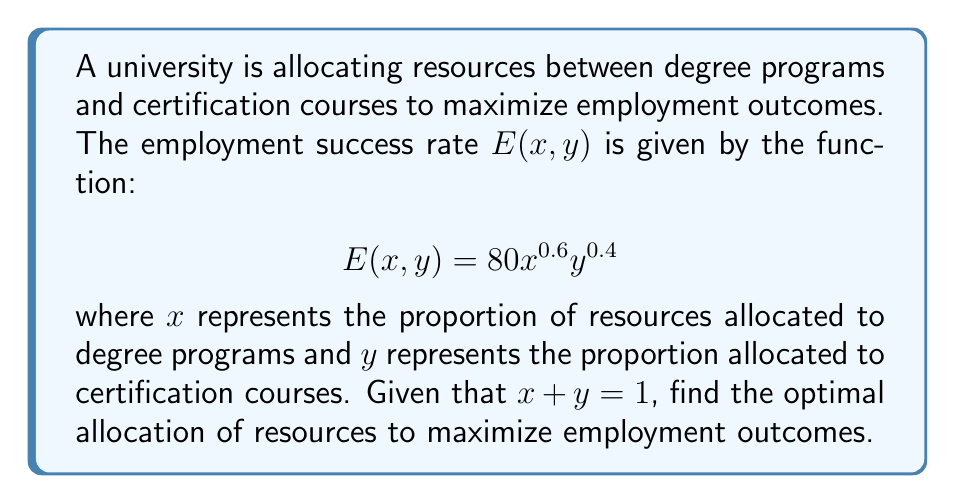What is the answer to this math problem? 1) First, we need to express $y$ in terms of $x$ using the constraint $x + y = 1$:
   $y = 1 - x$

2) Substitute this into the employment success rate function:
   $$E(x) = 80x^{0.6}(1-x)^{0.4}$$

3) To find the maximum, we need to differentiate $E(x)$ with respect to $x$ and set it to zero:
   $$\frac{dE}{dx} = 80[0.6x^{-0.4}(1-x)^{0.4} - 0.4x^{0.6}(1-x)^{-0.6}] = 0$$

4) Simplify:
   $$48x^{-0.4}(1-x)^{0.4} = 32x^{0.6}(1-x)^{-0.6}$$

5) Divide both sides by $32x^{-0.4}(1-x)^{-0.6}$:
   $$\frac{3(1-x)}{2x} = 1$$

6) Solve for $x$:
   $$3 - 3x = 2x$$
   $$3 = 5x$$
   $$x = \frac{3}{5} = 0.6$$

7) Therefore, $y = 1 - x = 1 - 0.6 = 0.4$

8) Check the second derivative to confirm this is a maximum:
   $$\frac{d^2E}{dx^2} < 0$$ at $x = 0.6$ (calculation omitted for brevity)
Answer: $x = 0.6$, $y = 0.4$ 